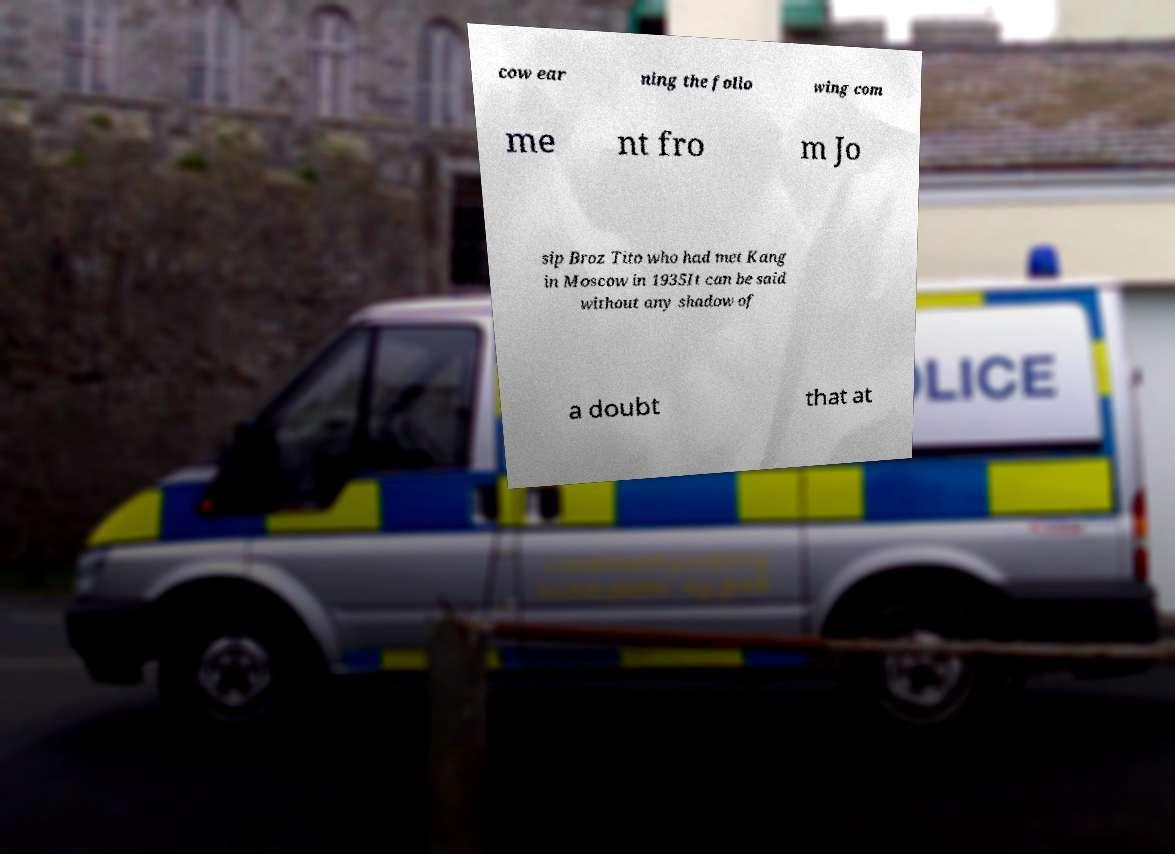Could you extract and type out the text from this image? cow ear ning the follo wing com me nt fro m Jo sip Broz Tito who had met Kang in Moscow in 1935It can be said without any shadow of a doubt that at 